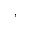<formula> <loc_0><loc_0><loc_500><loc_500>,</formula> 